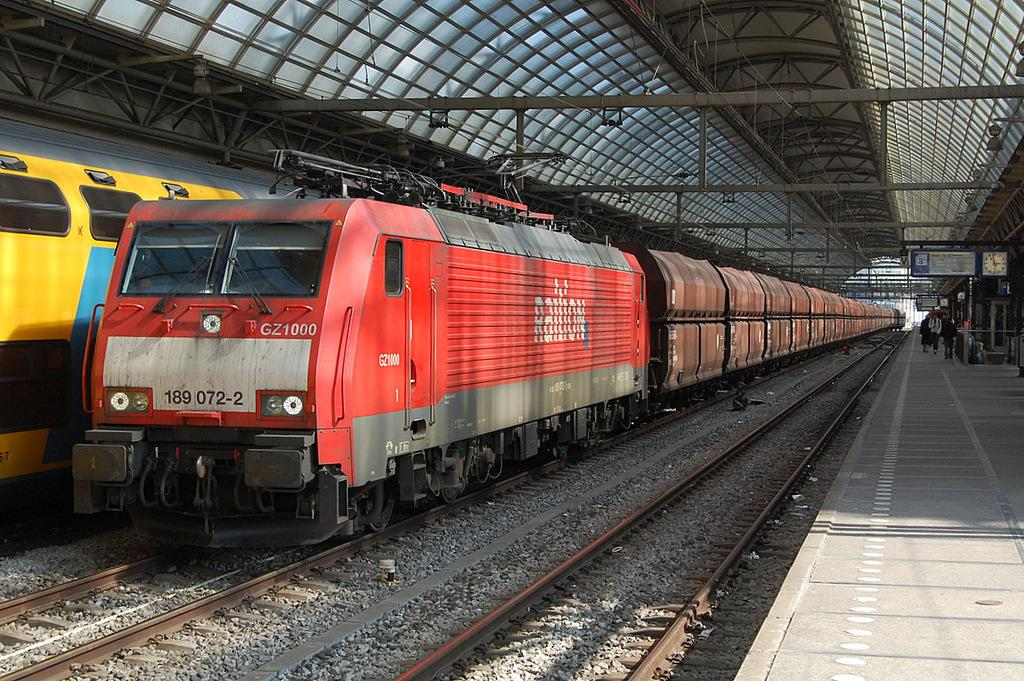What type of transportation infrastructure is present in the image? There is a railway track in the image. What vehicles are using the railway track? There are trains in the image. Is there a path for pedestrians in the image? Yes, there is a footpath in the image. Can you describe the people visible in the image? There are people visible in the image. What material is used for the roof in the image? The roof in the image is made of iron and sheet. What type of trick can be seen being performed by the people in the image? There is no trick being performed by the people in the image; they are simply visible. 